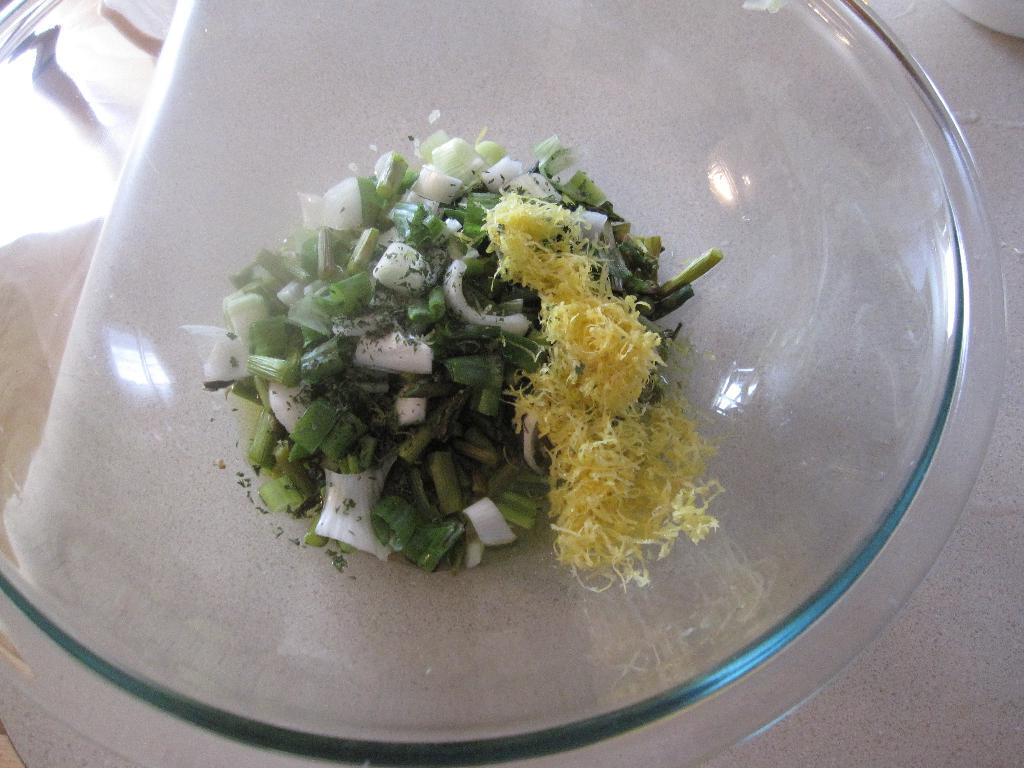What type of container is visible in the picture? There is a glass bowl in the picture. What is inside the glass bowl? There is food in the glass bowl. Where is the glass bowl located? The glass bowl is placed on a table. How many deer can be seen grazing near the glass bowl in the picture? There are no deer present in the image; it only features a glass bowl with food on a table. 